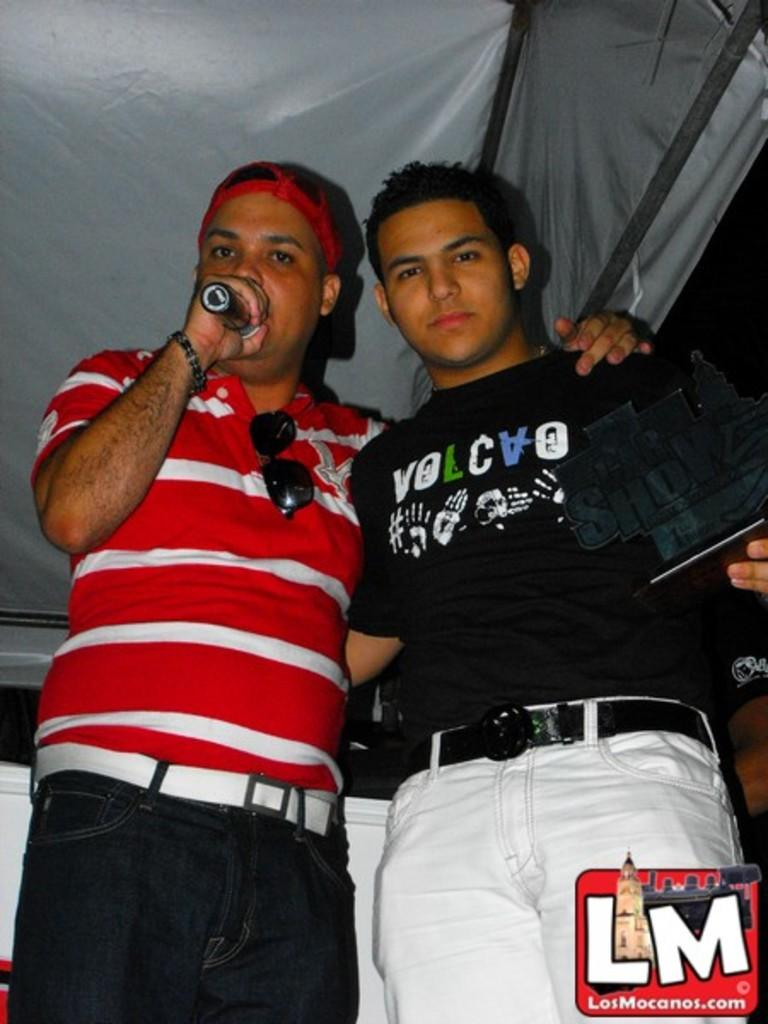Provide a one-sentence caption for the provided image. A man wears a black shirt with hand prints and "volcvo" on the front. 